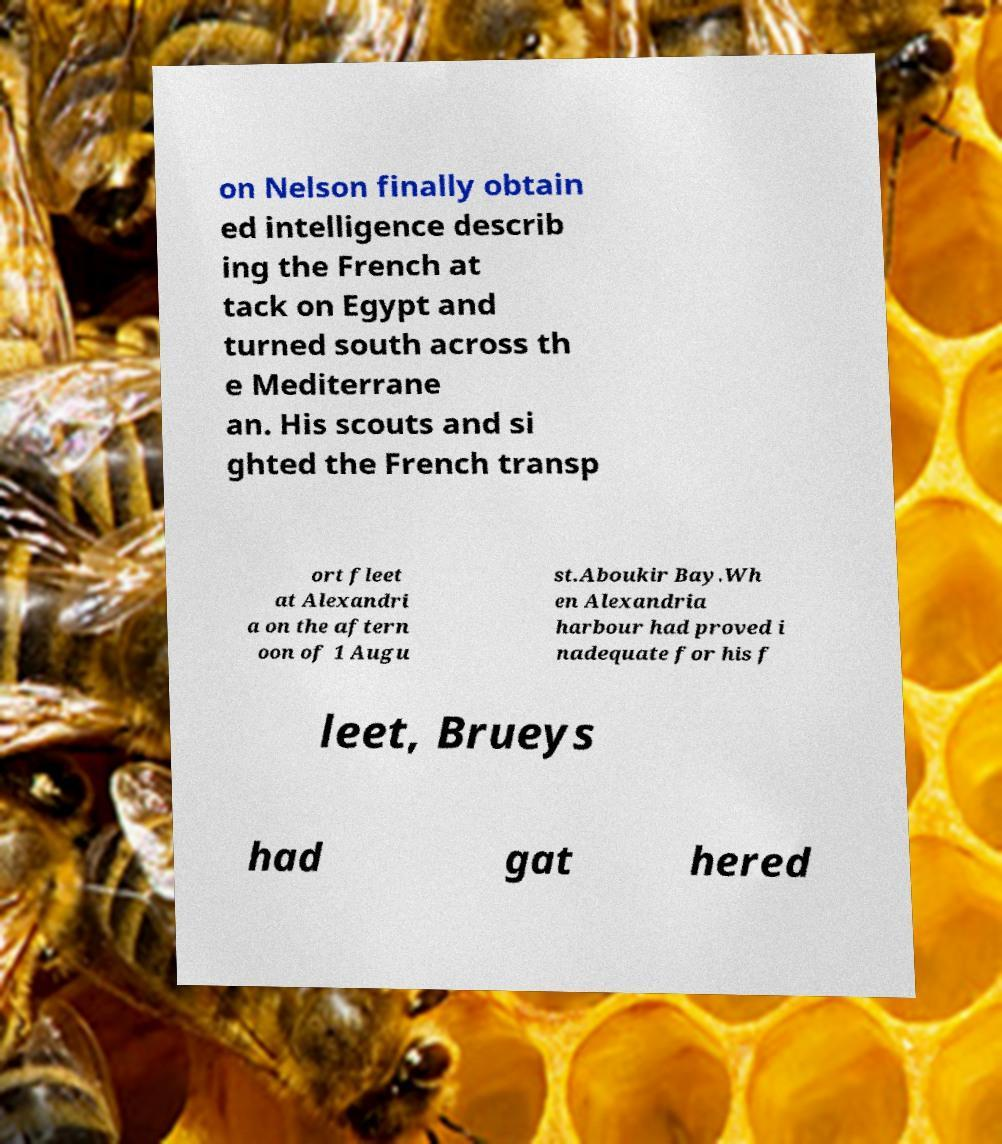Please identify and transcribe the text found in this image. on Nelson finally obtain ed intelligence describ ing the French at tack on Egypt and turned south across th e Mediterrane an. His scouts and si ghted the French transp ort fleet at Alexandri a on the aftern oon of 1 Augu st.Aboukir Bay.Wh en Alexandria harbour had proved i nadequate for his f leet, Brueys had gat hered 